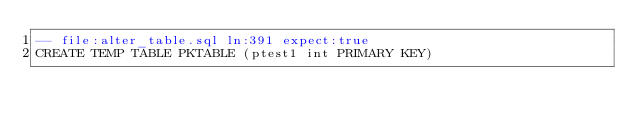Convert code to text. <code><loc_0><loc_0><loc_500><loc_500><_SQL_>-- file:alter_table.sql ln:391 expect:true
CREATE TEMP TABLE PKTABLE (ptest1 int PRIMARY KEY)
</code> 